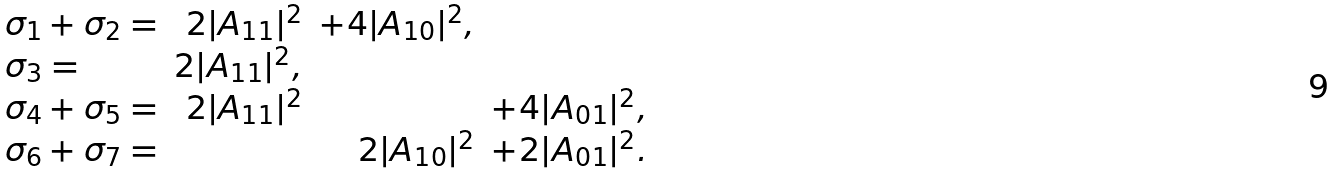Convert formula to latex. <formula><loc_0><loc_0><loc_500><loc_500>\begin{array} { l r r r } \sigma _ { 1 } + \sigma _ { 2 } = & 2 | A _ { 1 1 } | ^ { 2 } & + 4 | A _ { 1 0 } | ^ { 2 } , & \\ \sigma _ { 3 } = & 2 | A _ { 1 1 } | ^ { 2 } , & & \\ \sigma _ { 4 } + \sigma _ { 5 } = & 2 | A _ { 1 1 } | ^ { 2 } & & + 4 | A _ { 0 1 } | ^ { 2 } , \\ \sigma _ { 6 } + \sigma _ { 7 } = & & 2 | A _ { 1 0 } | ^ { 2 } & + 2 | A _ { 0 1 } | ^ { 2 } . \end{array}</formula> 